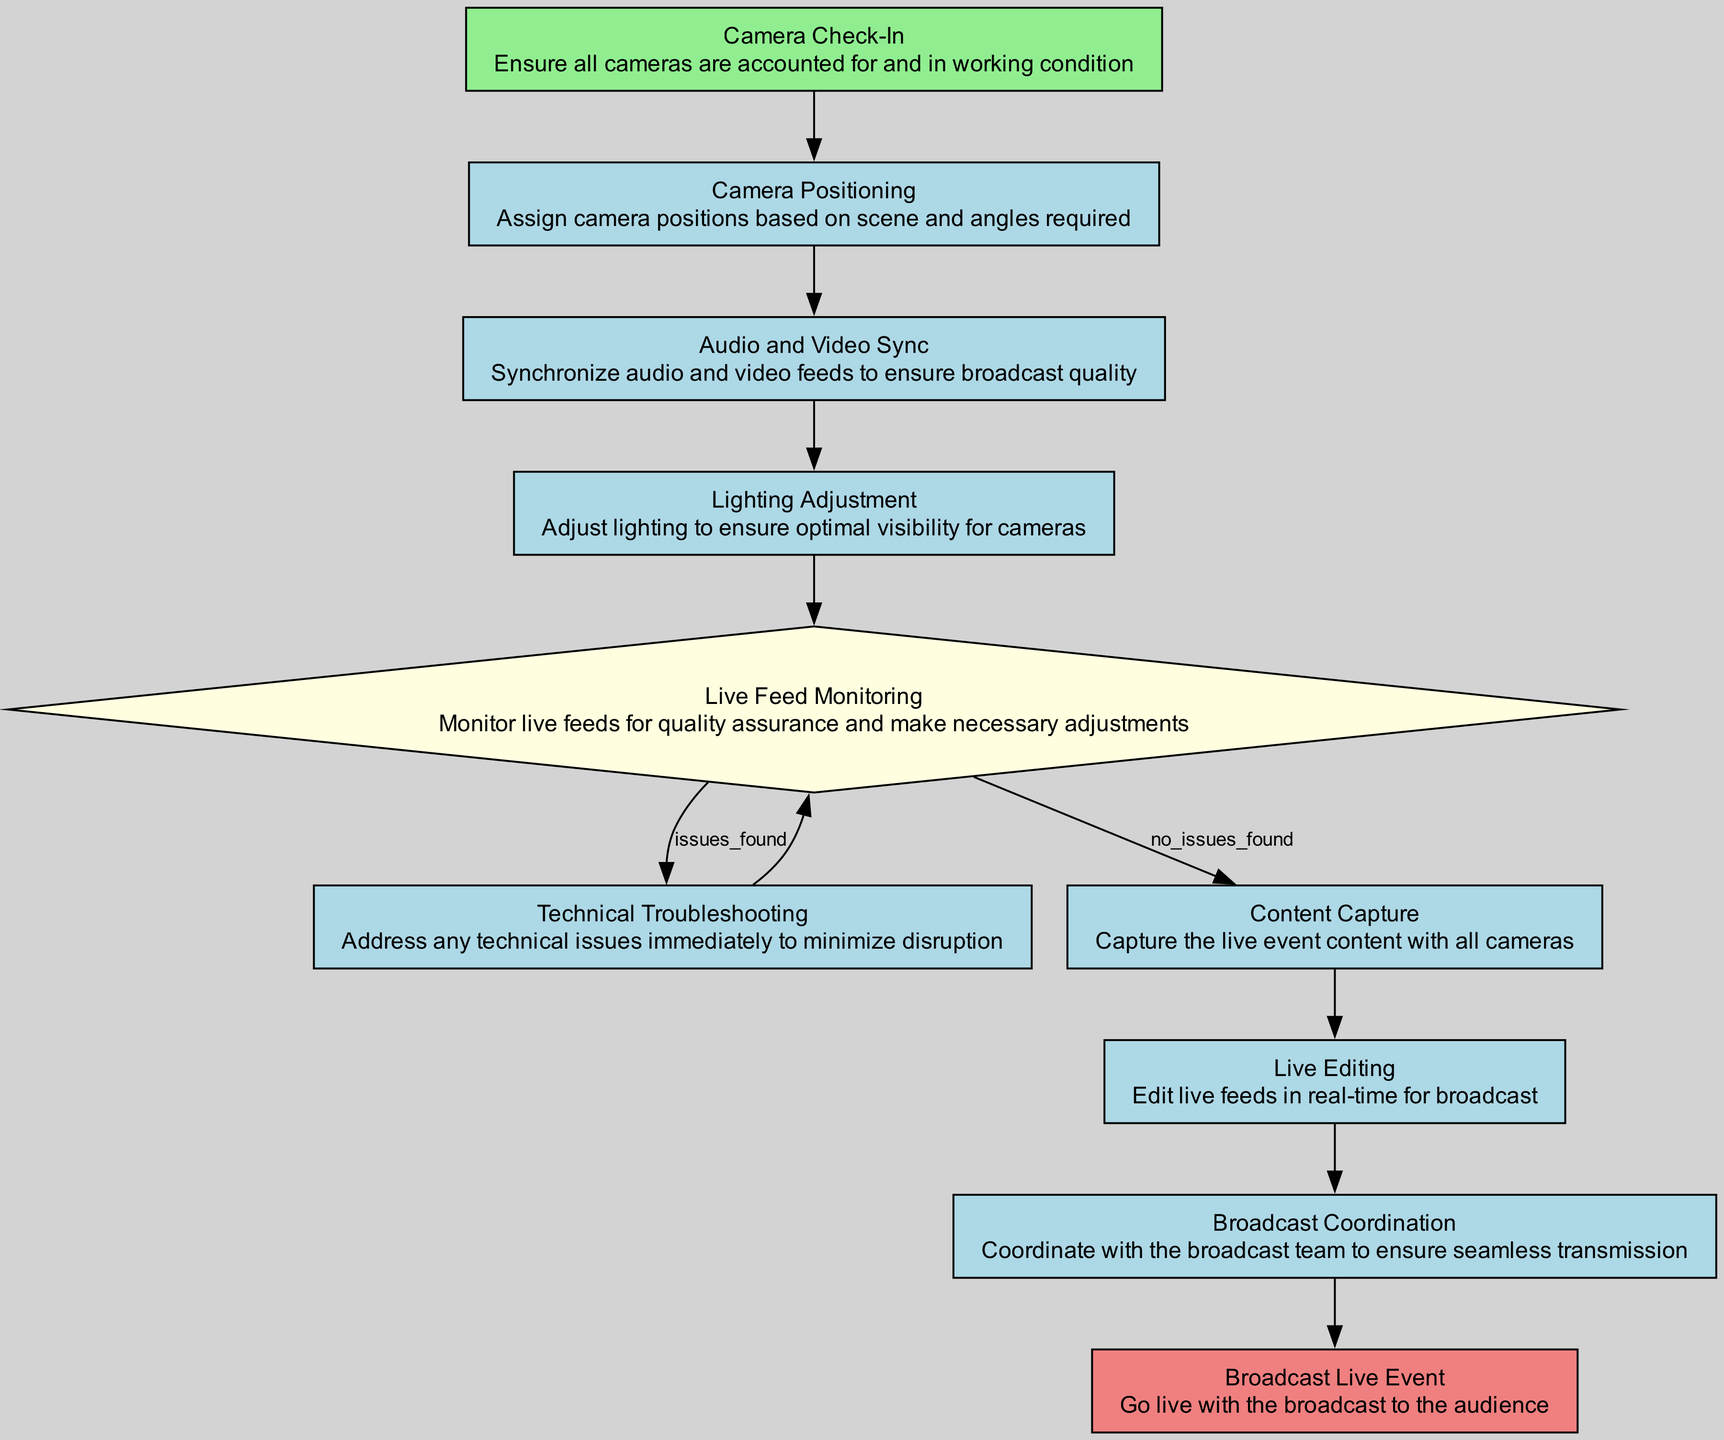What's the first step in the process? The flowchart indicates that the first step is "Camera Check-In," which is labeled as a start node.
Answer: Camera Check-In How many process nodes are in the diagram? By reviewing the flowchart, there are six process nodes: "Camera Positioning," "Audio and Video Sync," "Lighting Adjustment," "Technical Troubleshooting," "Content Capture," and "Live Editing."
Answer: Six What happens if issues are found during live feed monitoring? According to the diagram, if issues are found during "Live Feed Monitoring," the process leads to "Technical Troubleshooting" for immediate attention to the issues.
Answer: Technical Troubleshooting What is the final step in the process? The last step in the flowchart is "Broadcast Live Event," which is identified as the end node of the process.
Answer: Broadcast Live Event Which node follows "Audio and Video Sync"? The flowchart shows that the next node after "Audio and Video Sync" is "Lighting Adjustment," directly connected in the sequence.
Answer: Lighting Adjustment How many decision points are in the diagram? The diagram features one decision point, which is found in the "Live Feed Monitoring" node, where the outcome leads to different paths based on issues found or not.
Answer: One What is the last process before the broadcast event? The last process before reaching the "Broadcast Live Event" is "Broadcast Coordination," as per the flowchart's structure.
Answer: Broadcast Coordination What is the color associated with process nodes? Upon examining the diagram, all process nodes are filled with light blue color, differentiating them from start, end, and decision nodes.
Answer: Light blue 